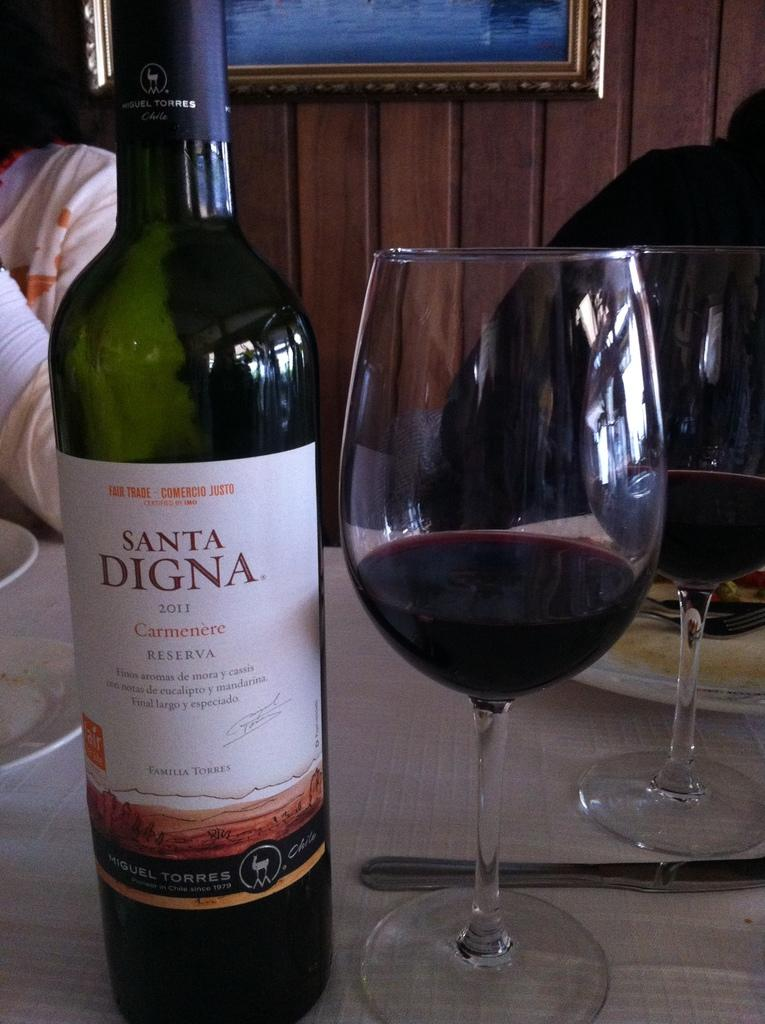<image>
Give a short and clear explanation of the subsequent image. A bottle of Santa Digna wine is next to half full glasses of wine. 